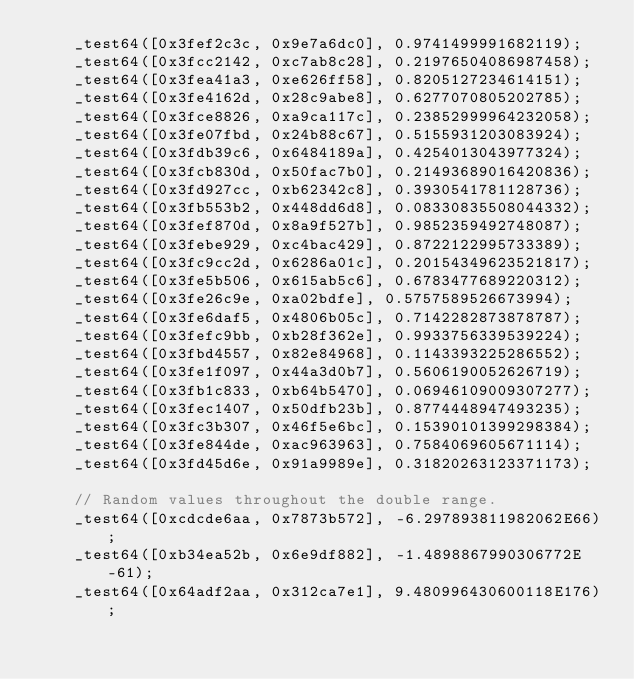Convert code to text. <code><loc_0><loc_0><loc_500><loc_500><_Dart_>    _test64([0x3fef2c3c, 0x9e7a6dc0], 0.9741499991682119);
    _test64([0x3fcc2142, 0xc7ab8c28], 0.21976504086987458);
    _test64([0x3fea41a3, 0xe626ff58], 0.8205127234614151);
    _test64([0x3fe4162d, 0x28c9abe8], 0.6277070805202785);
    _test64([0x3fce8826, 0xa9ca117c], 0.23852999964232058);
    _test64([0x3fe07fbd, 0x24b88c67], 0.5155931203083924);
    _test64([0x3fdb39c6, 0x6484189a], 0.4254013043977324);
    _test64([0x3fcb830d, 0x50fac7b0], 0.21493689016420836);
    _test64([0x3fd927cc, 0xb62342c8], 0.3930541781128736);
    _test64([0x3fb553b2, 0x448dd6d8], 0.08330835508044332);
    _test64([0x3fef870d, 0x8a9f527b], 0.9852359492748087);
    _test64([0x3febe929, 0xc4bac429], 0.8722122995733389);
    _test64([0x3fc9cc2d, 0x6286a01c], 0.20154349623521817);
    _test64([0x3fe5b506, 0x615ab5c6], 0.6783477689220312);
    _test64([0x3fe26c9e, 0xa02bdfe], 0.5757589526673994);
    _test64([0x3fe6daf5, 0x4806b05c], 0.7142282873878787);
    _test64([0x3fefc9bb, 0xb28f362e], 0.9933756339539224);
    _test64([0x3fbd4557, 0x82e84968], 0.1143393225286552);
    _test64([0x3fe1f097, 0x44a3d0b7], 0.5606190052626719);
    _test64([0x3fb1c833, 0xb64b5470], 0.06946109009307277);
    _test64([0x3fec1407, 0x50dfb23b], 0.8774448947493235);
    _test64([0x3fc3b307, 0x46f5e6bc], 0.15390101399298384);
    _test64([0x3fe844de, 0xac963963], 0.7584069605671114);
    _test64([0x3fd45d6e, 0x91a9989e], 0.31820263123371173);

    // Random values throughout the double range.
    _test64([0xcdcde6aa, 0x7873b572], -6.297893811982062E66);
    _test64([0xb34ea52b, 0x6e9df882], -1.4898867990306772E-61);
    _test64([0x64adf2aa, 0x312ca7e1], 9.480996430600118E176);</code> 